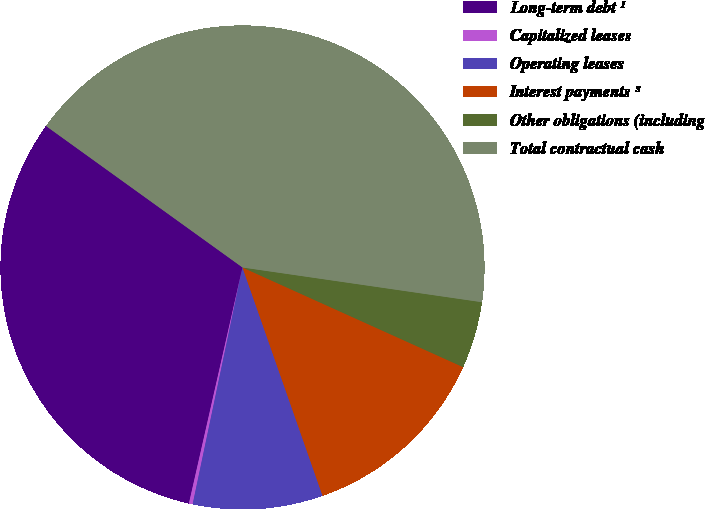Convert chart. <chart><loc_0><loc_0><loc_500><loc_500><pie_chart><fcel>Long-term debt ¹<fcel>Capitalized leases<fcel>Operating leases<fcel>Interest payments ³<fcel>Other obligations (including<fcel>Total contractual cash<nl><fcel>31.38%<fcel>0.25%<fcel>8.67%<fcel>12.88%<fcel>4.46%<fcel>42.36%<nl></chart> 